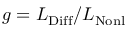Convert formula to latex. <formula><loc_0><loc_0><loc_500><loc_500>g = L _ { D i f f } / L _ { N o n l }</formula> 